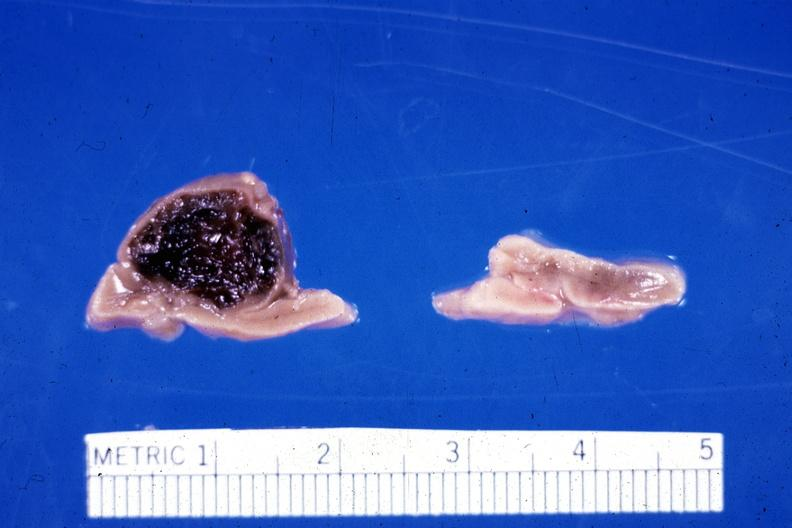had adrenal of premature 30 week gestation gram infant lesion ruptured causing 20 ml hemoperitoneum?
Answer the question using a single word or phrase. Yes 